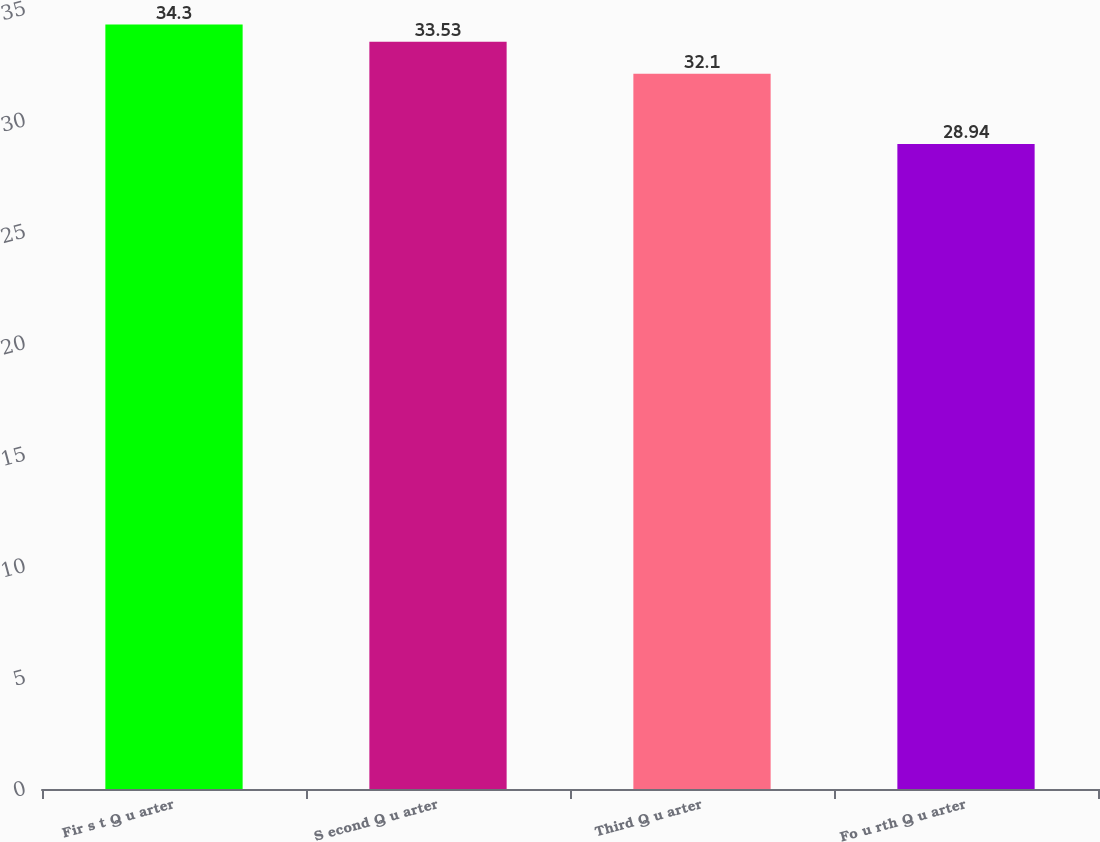Convert chart. <chart><loc_0><loc_0><loc_500><loc_500><bar_chart><fcel>Fir s t Q u arter<fcel>S econd Q u arter<fcel>Third Q u arter<fcel>Fo u rth Q u arter<nl><fcel>34.3<fcel>33.53<fcel>32.1<fcel>28.94<nl></chart> 